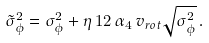<formula> <loc_0><loc_0><loc_500><loc_500>\tilde { \sigma } _ { \phi } ^ { 2 } = \sigma _ { \phi } ^ { 2 } + \eta \, 1 2 \, \alpha _ { 4 } \, v _ { r o t } \sqrt { \sigma _ { \phi } ^ { 2 } } \, .</formula> 